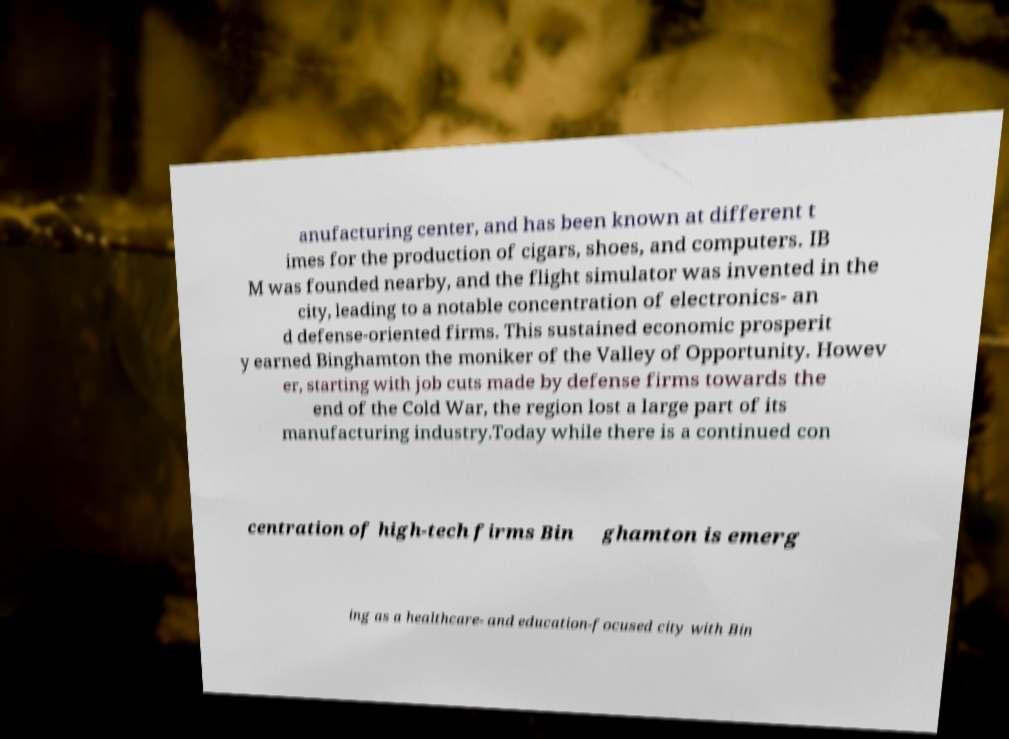Can you accurately transcribe the text from the provided image for me? anufacturing center, and has been known at different t imes for the production of cigars, shoes, and computers. IB M was founded nearby, and the flight simulator was invented in the city, leading to a notable concentration of electronics- an d defense-oriented firms. This sustained economic prosperit y earned Binghamton the moniker of the Valley of Opportunity. Howev er, starting with job cuts made by defense firms towards the end of the Cold War, the region lost a large part of its manufacturing industry.Today while there is a continued con centration of high-tech firms Bin ghamton is emerg ing as a healthcare- and education-focused city with Bin 